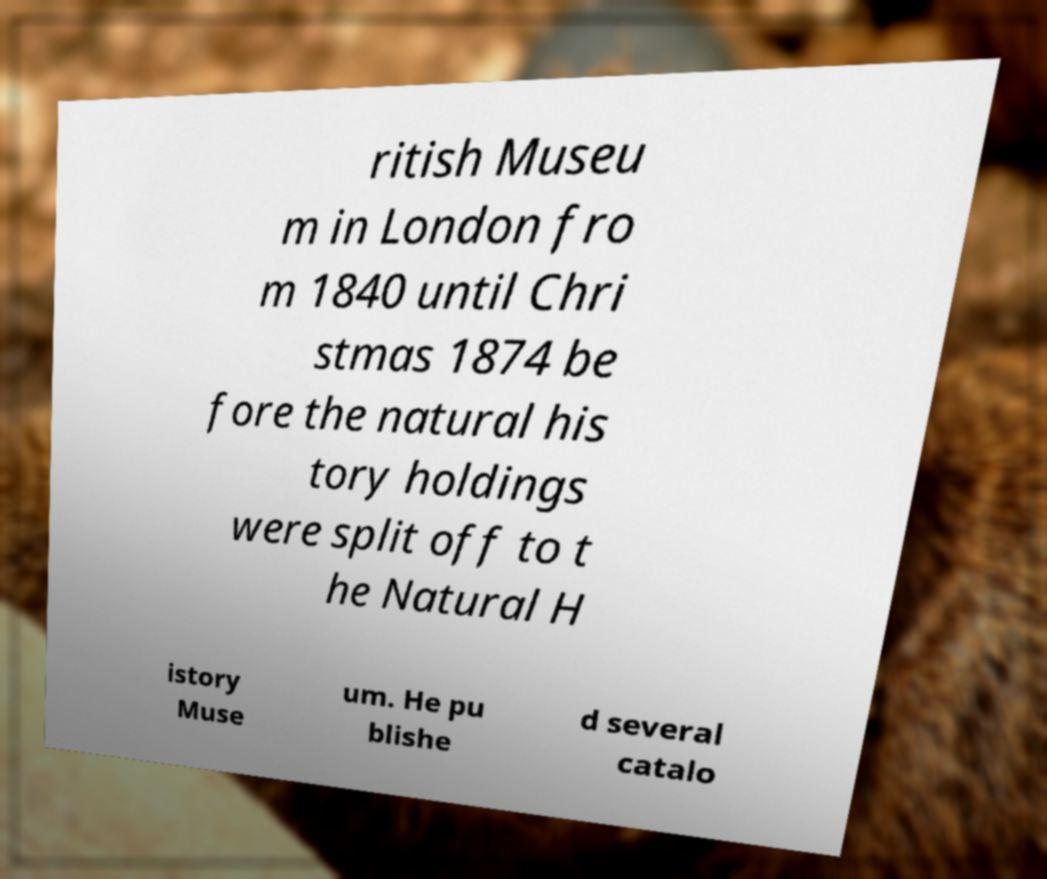There's text embedded in this image that I need extracted. Can you transcribe it verbatim? ritish Museu m in London fro m 1840 until Chri stmas 1874 be fore the natural his tory holdings were split off to t he Natural H istory Muse um. He pu blishe d several catalo 